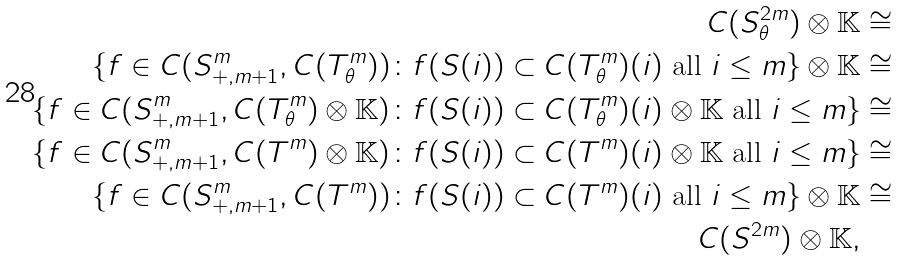Convert formula to latex. <formula><loc_0><loc_0><loc_500><loc_500>C ( S ^ { 2 m } _ { \theta } ) \otimes \mathbb { K } & \cong \\ \{ f \in C ( S ^ { m } _ { + , m + 1 } , C ( T ^ { m } _ { \theta } ) ) \colon f ( S ( i ) ) \subset C ( T ^ { m } _ { \theta } ) ( i ) \text { all } i \leq m \} \otimes \mathbb { K } & \cong \\ \{ f \in C ( S ^ { m } _ { + , m + 1 } , C ( T ^ { m } _ { \theta } ) \otimes \mathbb { K } ) \colon f ( S ( i ) ) \subset C ( T ^ { m } _ { \theta } ) ( i ) \otimes \mathbb { K } \text { all } i \leq m \} & \cong \\ \{ f \in C ( S ^ { m } _ { + , m + 1 } , C ( T ^ { m } ) \otimes \mathbb { K } ) \colon f ( S ( i ) ) \subset C ( T ^ { m } ) ( i ) \otimes \mathbb { K } \text { all } i \leq m \} & \cong \\ \{ f \in C ( S ^ { m } _ { + , m + 1 } , C ( T ^ { m } ) ) \colon f ( S ( i ) ) \subset C ( T ^ { m } ) ( i ) \text { all } i \leq m \} \otimes \mathbb { K } & \cong \\ C ( S ^ { 2 m } ) \otimes \mathbb { K } ,</formula> 